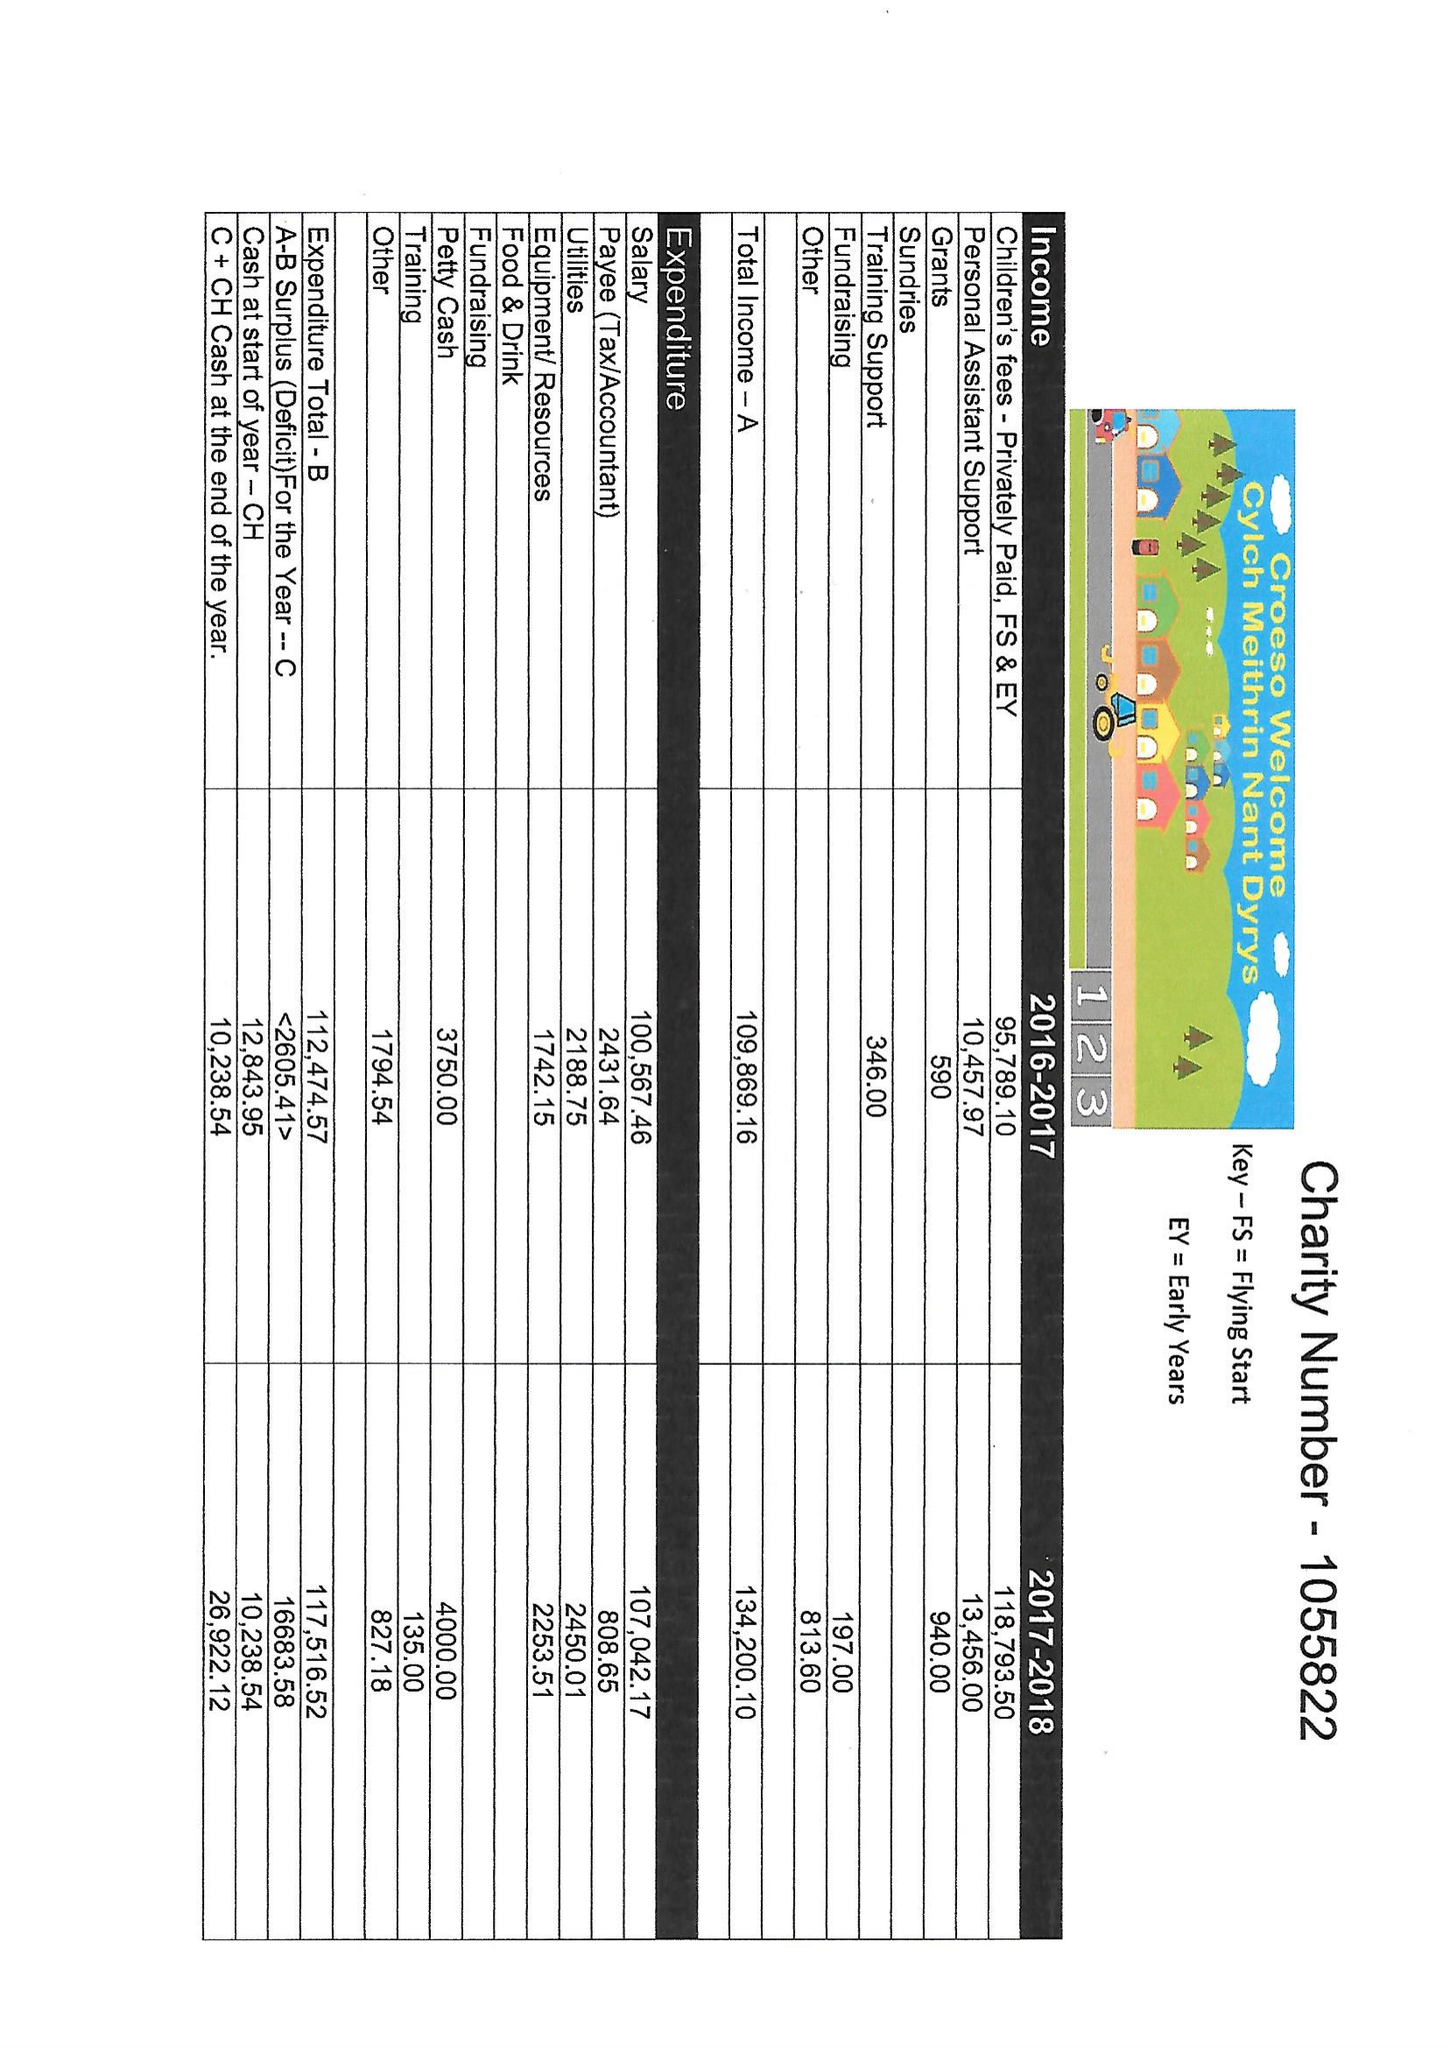What is the value for the charity_name?
Answer the question using a single word or phrase. Cylch Meithrin Nant Dyrys 